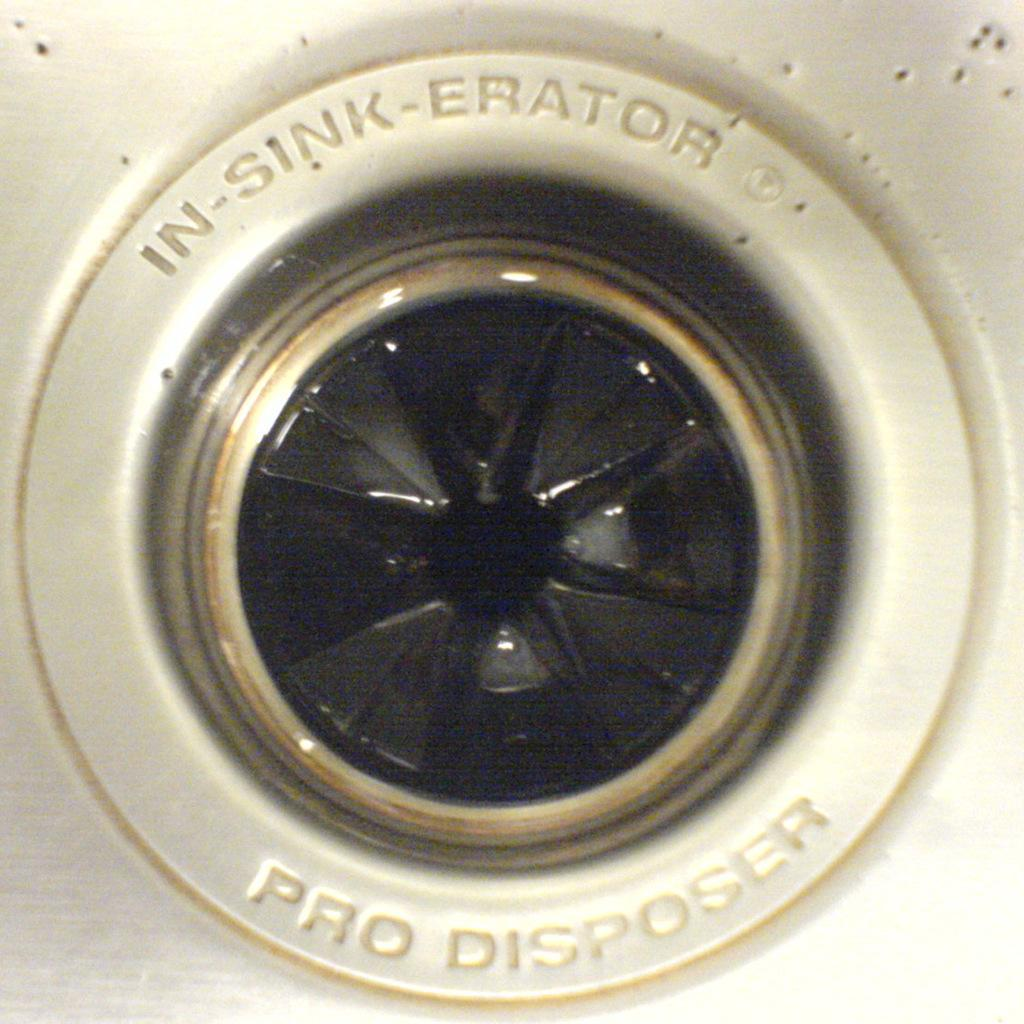What object is the main focus of the image? The main focus of the image is a garbage disposal. What can be seen on the garbage disposal? There is writing on the garbage disposal. What type of news is being broadcasted on the farm in the image? There is no farm or news broadcast present in the image; it features a garbage disposal with writing on it. What color is the cord attached to the farm in the image? There is no farm or cord present in the image. 